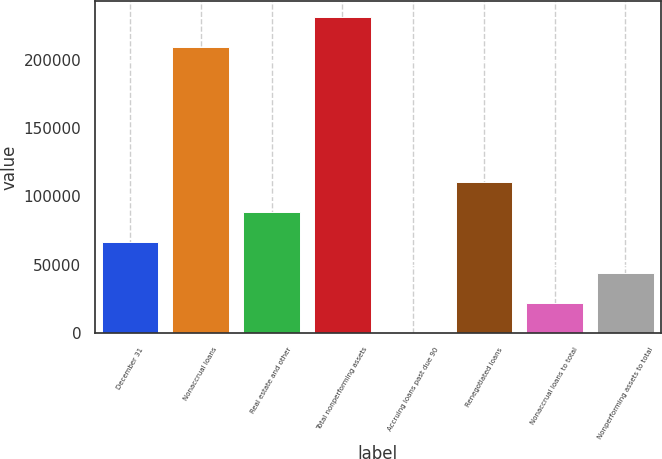Convert chart. <chart><loc_0><loc_0><loc_500><loc_500><bar_chart><fcel>December 31<fcel>Nonaccrual loans<fcel>Real estate and other<fcel>Total nonperforming assets<fcel>Accruing loans past due 90<fcel>Renegotiated loans<fcel>Nonaccrual loans to total<fcel>Nonperforming assets to total<nl><fcel>66424.1<fcel>209272<fcel>88565.3<fcel>231413<fcel>0.26<fcel>110707<fcel>22141.5<fcel>44282.8<nl></chart> 